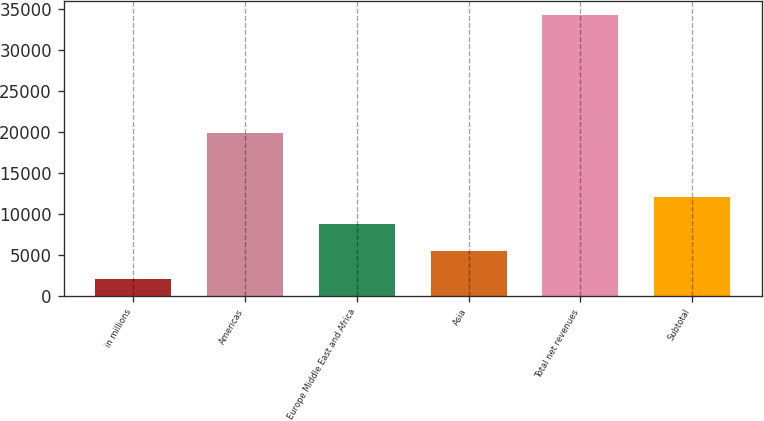<chart> <loc_0><loc_0><loc_500><loc_500><bar_chart><fcel>in millions<fcel>Americas<fcel>Europe Middle East and Africa<fcel>Asia<fcel>Total net revenues<fcel>Subtotal<nl><fcel>2013<fcel>19858<fcel>8828<fcel>5520<fcel>34206<fcel>12047.3<nl></chart> 